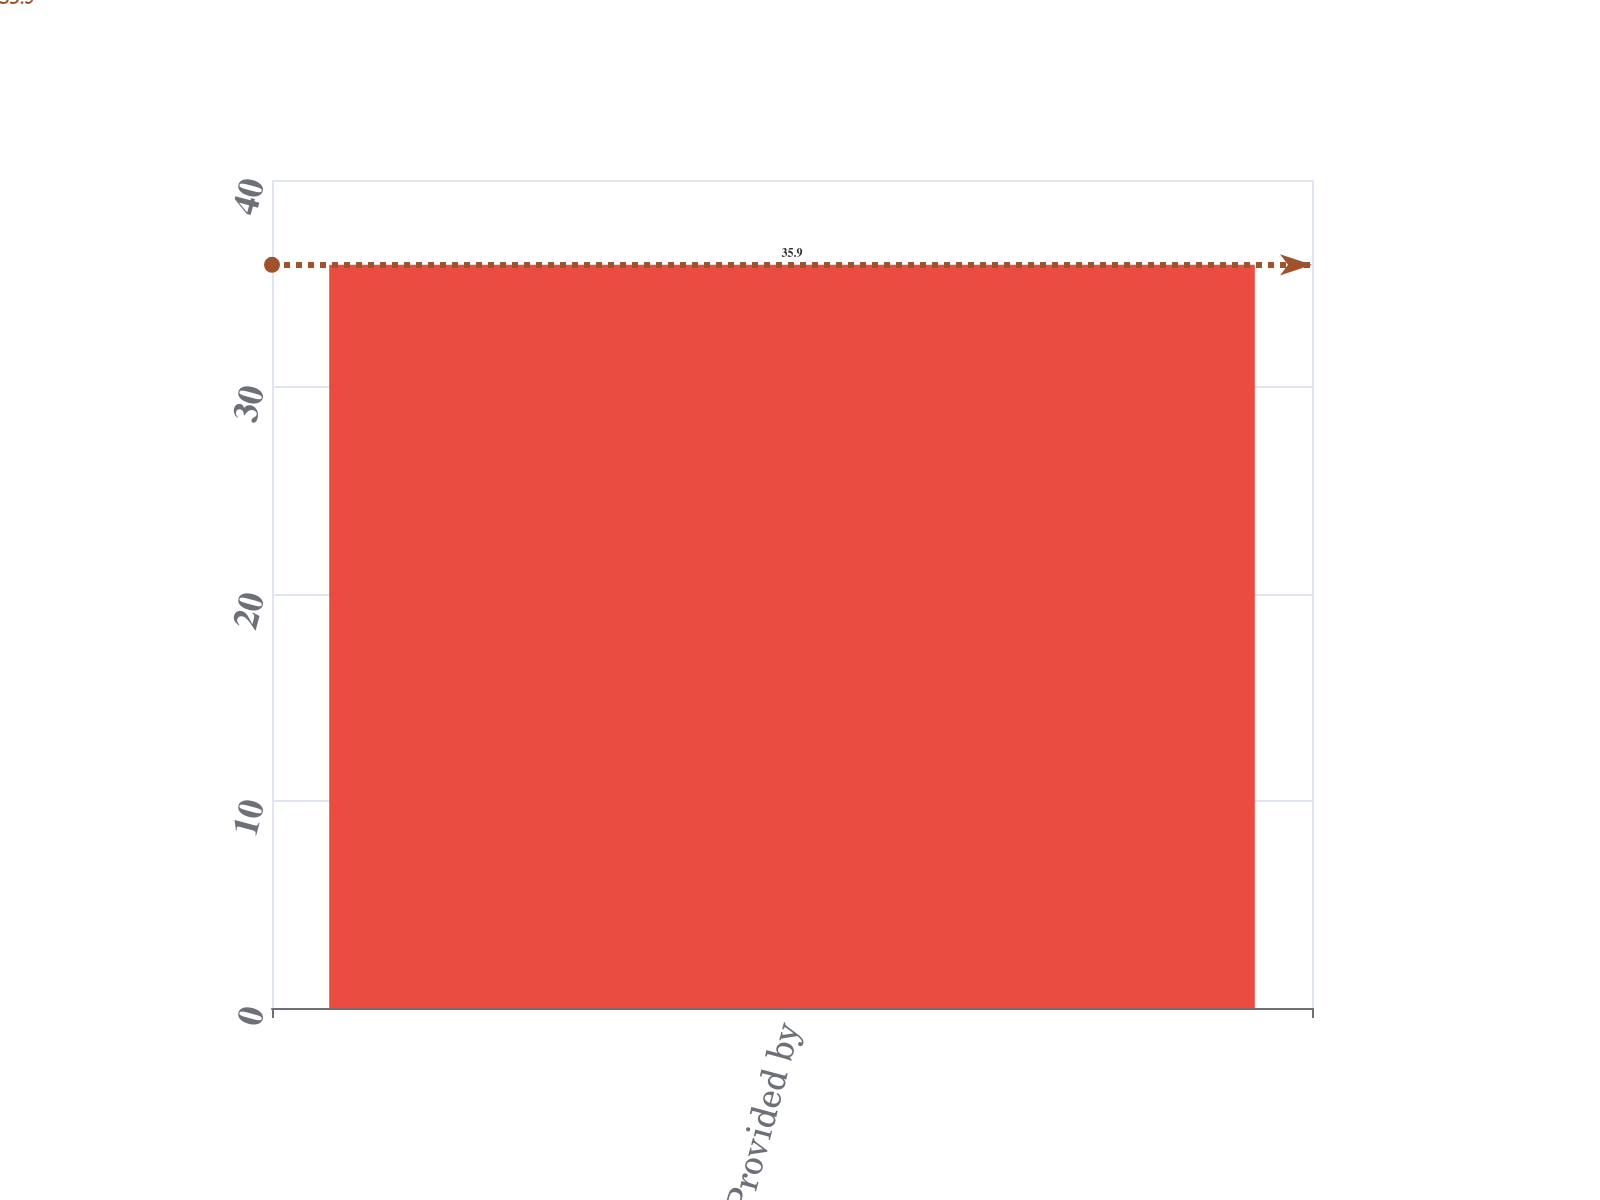Convert chart to OTSL. <chart><loc_0><loc_0><loc_500><loc_500><bar_chart><fcel>Net Cash Provided by<nl><fcel>35.9<nl></chart> 